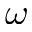<formula> <loc_0><loc_0><loc_500><loc_500>\omega</formula> 